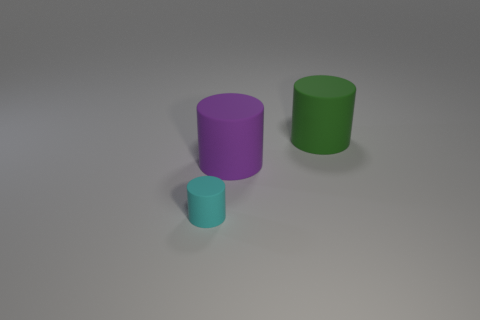Subtract all large cylinders. How many cylinders are left? 1 Add 1 big purple cylinders. How many objects exist? 4 Add 2 blue rubber spheres. How many blue rubber spheres exist? 2 Subtract 0 brown balls. How many objects are left? 3 Subtract all green objects. Subtract all green matte cylinders. How many objects are left? 1 Add 3 small objects. How many small objects are left? 4 